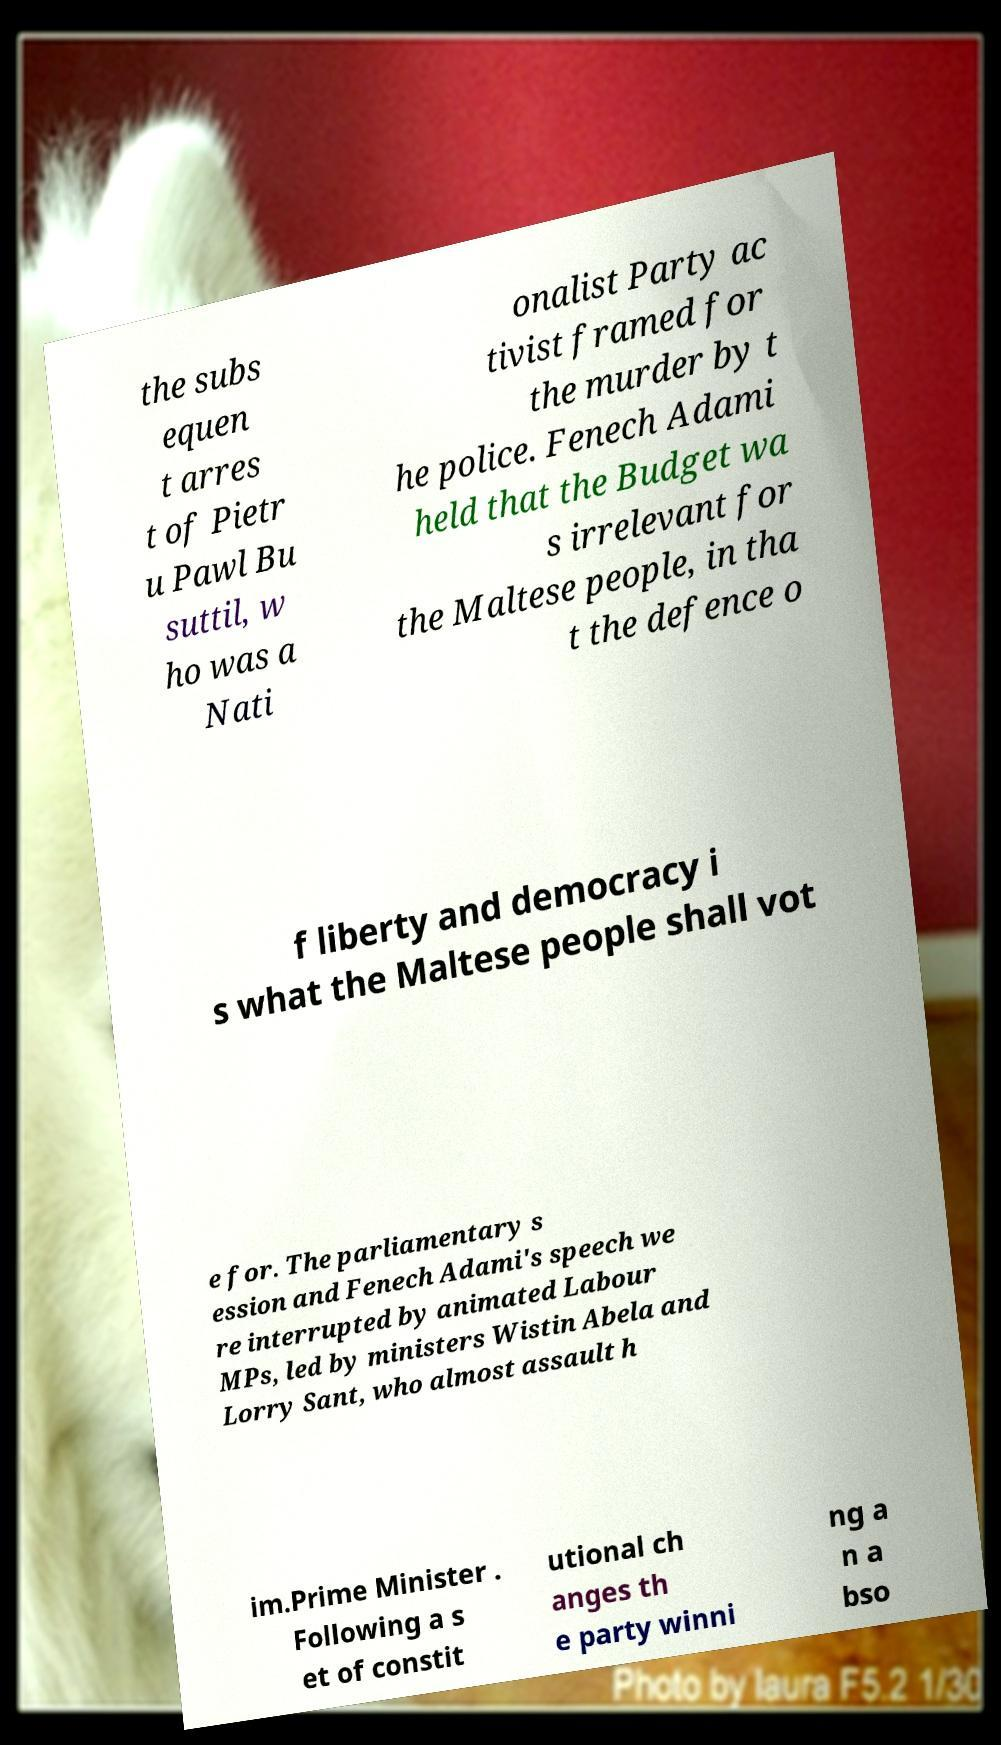I need the written content from this picture converted into text. Can you do that? the subs equen t arres t of Pietr u Pawl Bu suttil, w ho was a Nati onalist Party ac tivist framed for the murder by t he police. Fenech Adami held that the Budget wa s irrelevant for the Maltese people, in tha t the defence o f liberty and democracy i s what the Maltese people shall vot e for. The parliamentary s ession and Fenech Adami's speech we re interrupted by animated Labour MPs, led by ministers Wistin Abela and Lorry Sant, who almost assault h im.Prime Minister . Following a s et of constit utional ch anges th e party winni ng a n a bso 